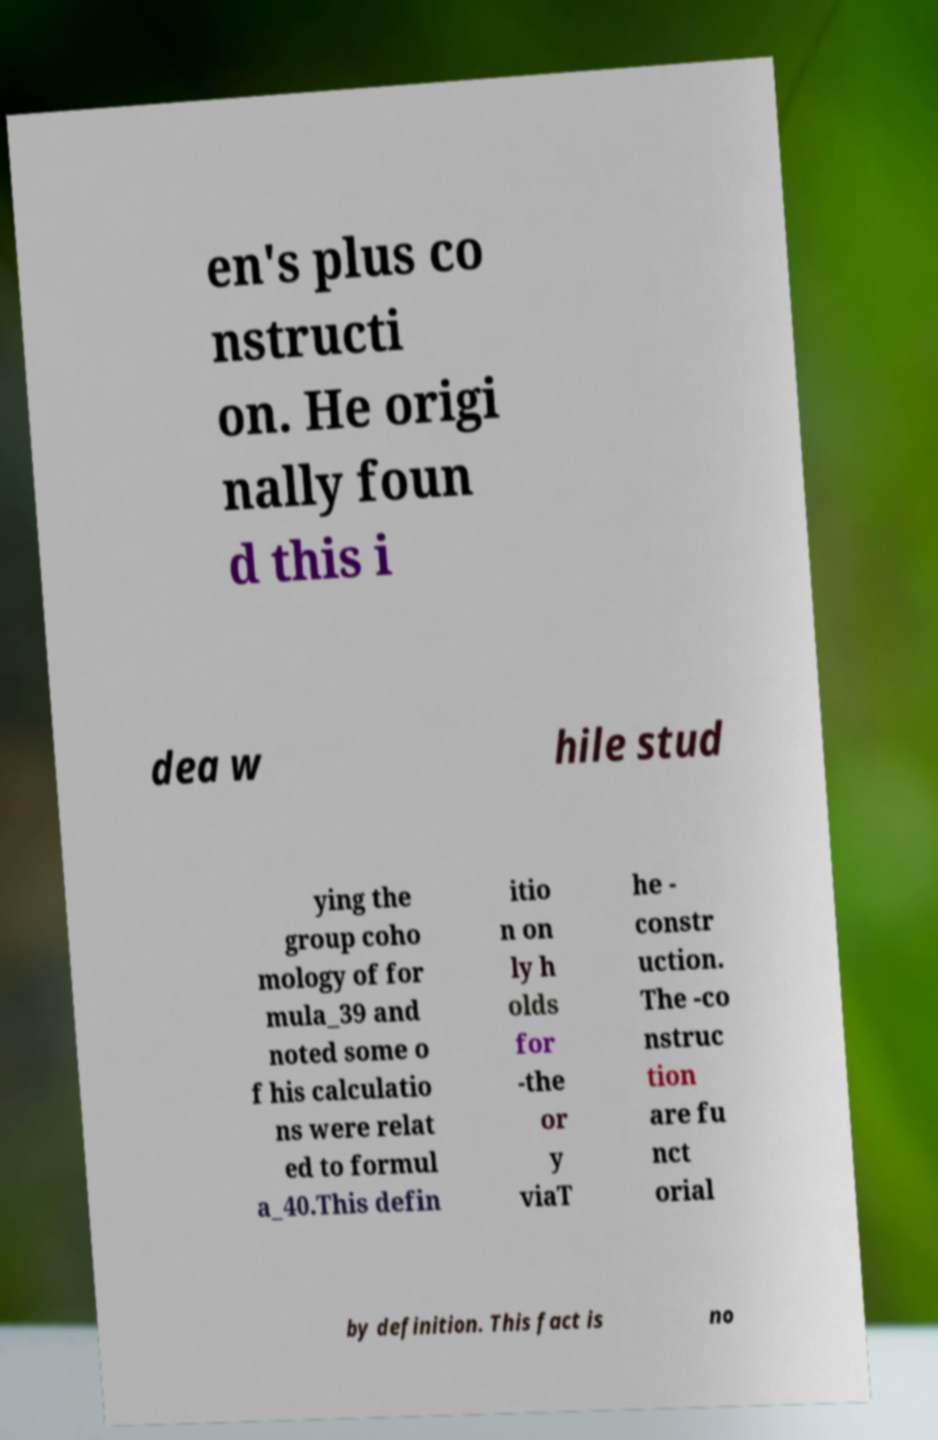For documentation purposes, I need the text within this image transcribed. Could you provide that? en's plus co nstructi on. He origi nally foun d this i dea w hile stud ying the group coho mology of for mula_39 and noted some o f his calculatio ns were relat ed to formul a_40.This defin itio n on ly h olds for -the or y viaT he - constr uction. The -co nstruc tion are fu nct orial by definition. This fact is no 